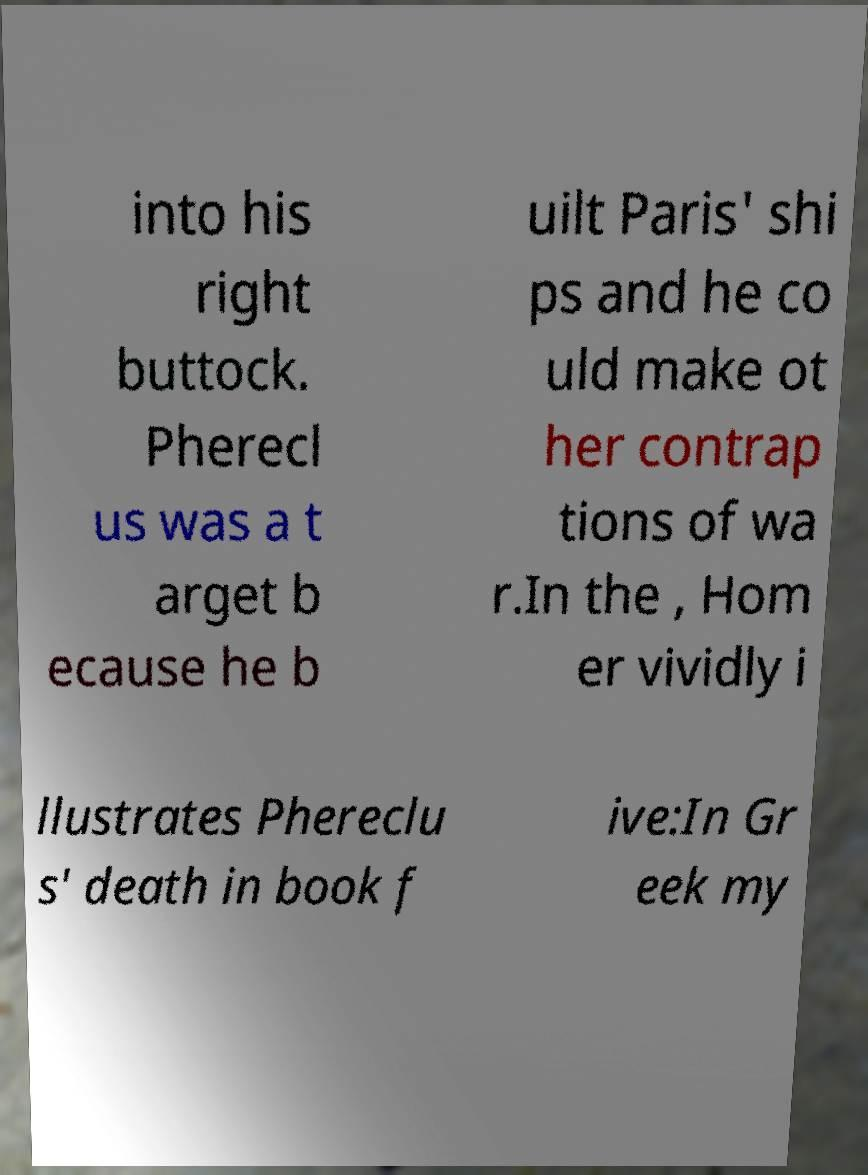There's text embedded in this image that I need extracted. Can you transcribe it verbatim? into his right buttock. Pherecl us was a t arget b ecause he b uilt Paris' shi ps and he co uld make ot her contrap tions of wa r.In the , Hom er vividly i llustrates Phereclu s' death in book f ive:In Gr eek my 